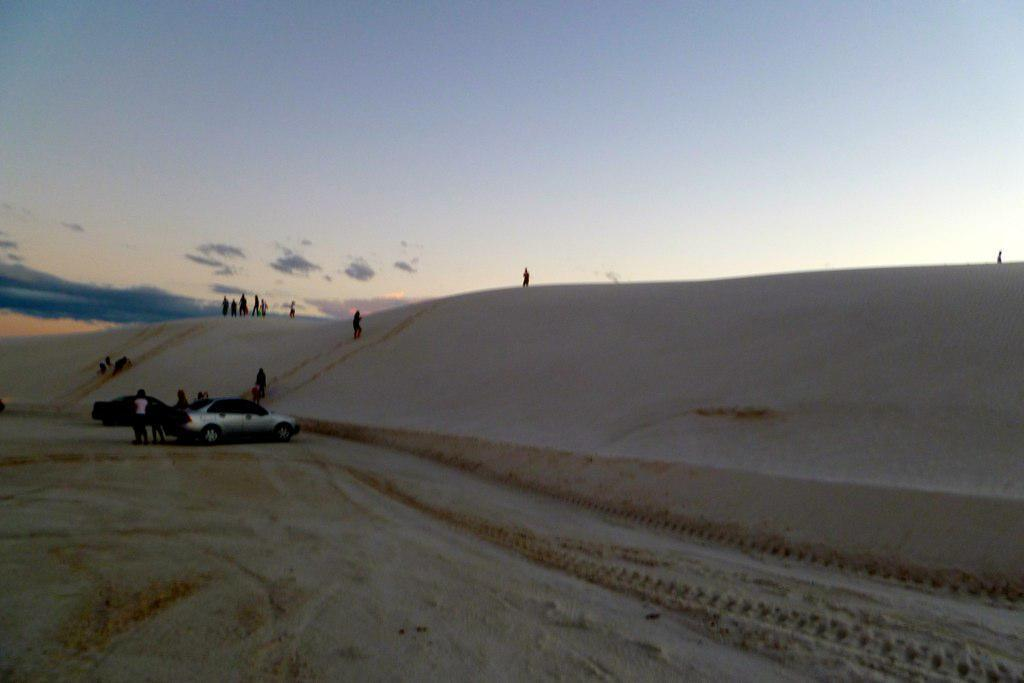What type of terrain is visible in the image? There is sand in the image. What vehicles are present on the sand? There are two cars on the sand. Are there any people in the image? Yes, there are people in the image. What can be seen in the background of the image? The sky is visible in the background of the image. What type of rhythm can be heard coming from the cars in the image? There is no sound or rhythm present in the image, as it is a still photograph. 